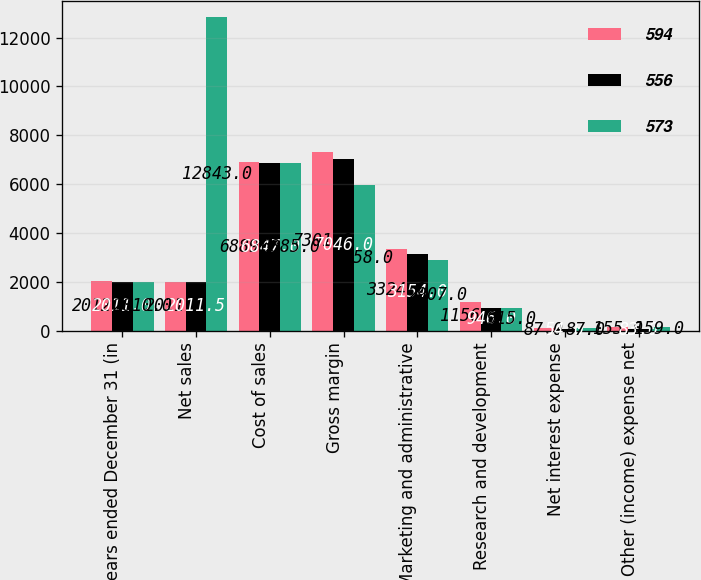Convert chart to OTSL. <chart><loc_0><loc_0><loc_500><loc_500><stacked_bar_chart><ecel><fcel>years ended December 31 (in<fcel>Net sales<fcel>Cost of sales<fcel>Gross margin<fcel>Marketing and administrative<fcel>Research and development<fcel>Net interest expense<fcel>Other (income) expense net<nl><fcel>594<fcel>2012<fcel>2011.5<fcel>6889<fcel>7301<fcel>3324<fcel>1156<fcel>87<fcel>155<nl><fcel>556<fcel>2011<fcel>2011.5<fcel>6847<fcel>7046<fcel>3154<fcel>946<fcel>54<fcel>83<nl><fcel>573<fcel>2010<fcel>12843<fcel>6885<fcel>5958<fcel>2907<fcel>915<fcel>87<fcel>159<nl></chart> 